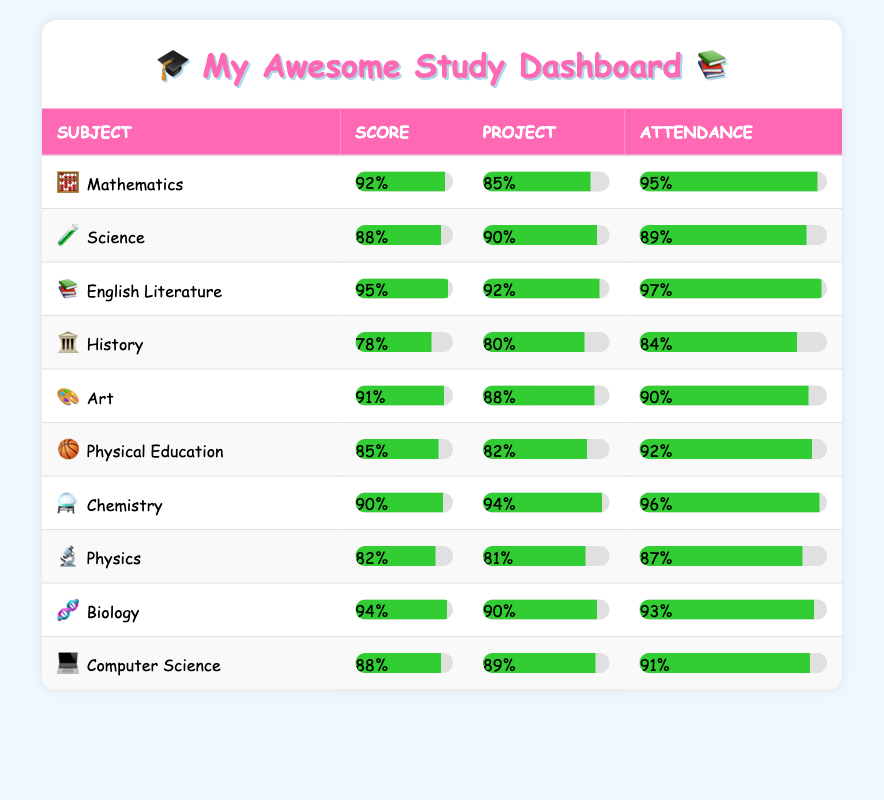What is the highest score achieved in Mathematics? From the table, we see that Alice Johnson scored 92 in Mathematics, which is the maximum score listed for that subject.
Answer: 92 Which student received the lowest project score in History? Reviewing the table, David Wilson scored 80 on his History project, which is the only project score for History and the lowest in the table across all subjects.
Answer: 80 What is the average attendance score across all subjects? To find the average attendance, we sum the attendance scores (95 + 89 + 97 + 84 + 90 + 92 + 96 + 87 + 93 + 91 = 915) and divide by the number of students (10). Thus, 915 / 10 = 91.5.
Answer: 91.5 Is it true that all students scored above 80 in their subjects? By checking each student's score, we find that David Wilson scored 78 in History, which is below 80, thus making the statement false.
Answer: No Which subject had the highest attendance score and what was the value? Analyzing the attendance scores, the highest is 97, achieved by Charlotte Brown in English Literature, making it the subject with the best attendance.
Answer: 97 What is the total score of Frank Thomas in Physical Education, including both the test and the project? Frank's score in Physical Education is 85, and his project score is 82. Adding them together gives us 85 + 82 = 167.
Answer: 167 Which student has the highest combined score (test + project) in Biology? Isabella Wilson scored 94 in Biology and had a project score of 90. Adding those together (94 + 90 = 184), she has the highest combined score in that subject.
Answer: 184 What is the total project score from all subjects? Adding the project scores for all subjects gives us (85 + 90 + 92 + 80 + 88 + 82 + 94 + 81 + 90 + 89 =  900). Therefore, the total project score is 900.
Answer: 900 Which two subjects had the closest attendance score and what were they? Comparing attendance scores, Physical Education (92) and Science (89) have the closest values, with a difference of three points.
Answer: 92 and 89 